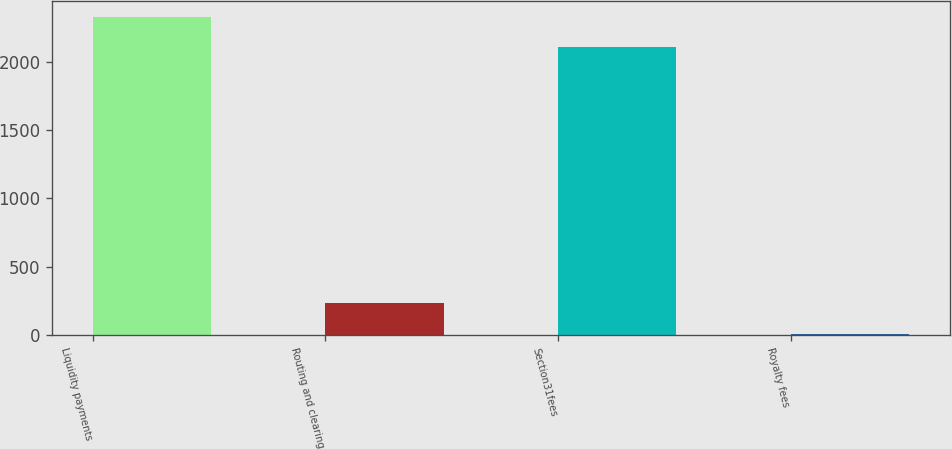Convert chart to OTSL. <chart><loc_0><loc_0><loc_500><loc_500><bar_chart><fcel>Liquidity payments<fcel>Routing and clearing<fcel>Section31fees<fcel>Royalty fees<nl><fcel>2329.7<fcel>238.7<fcel>2103.4<fcel>10.5<nl></chart> 